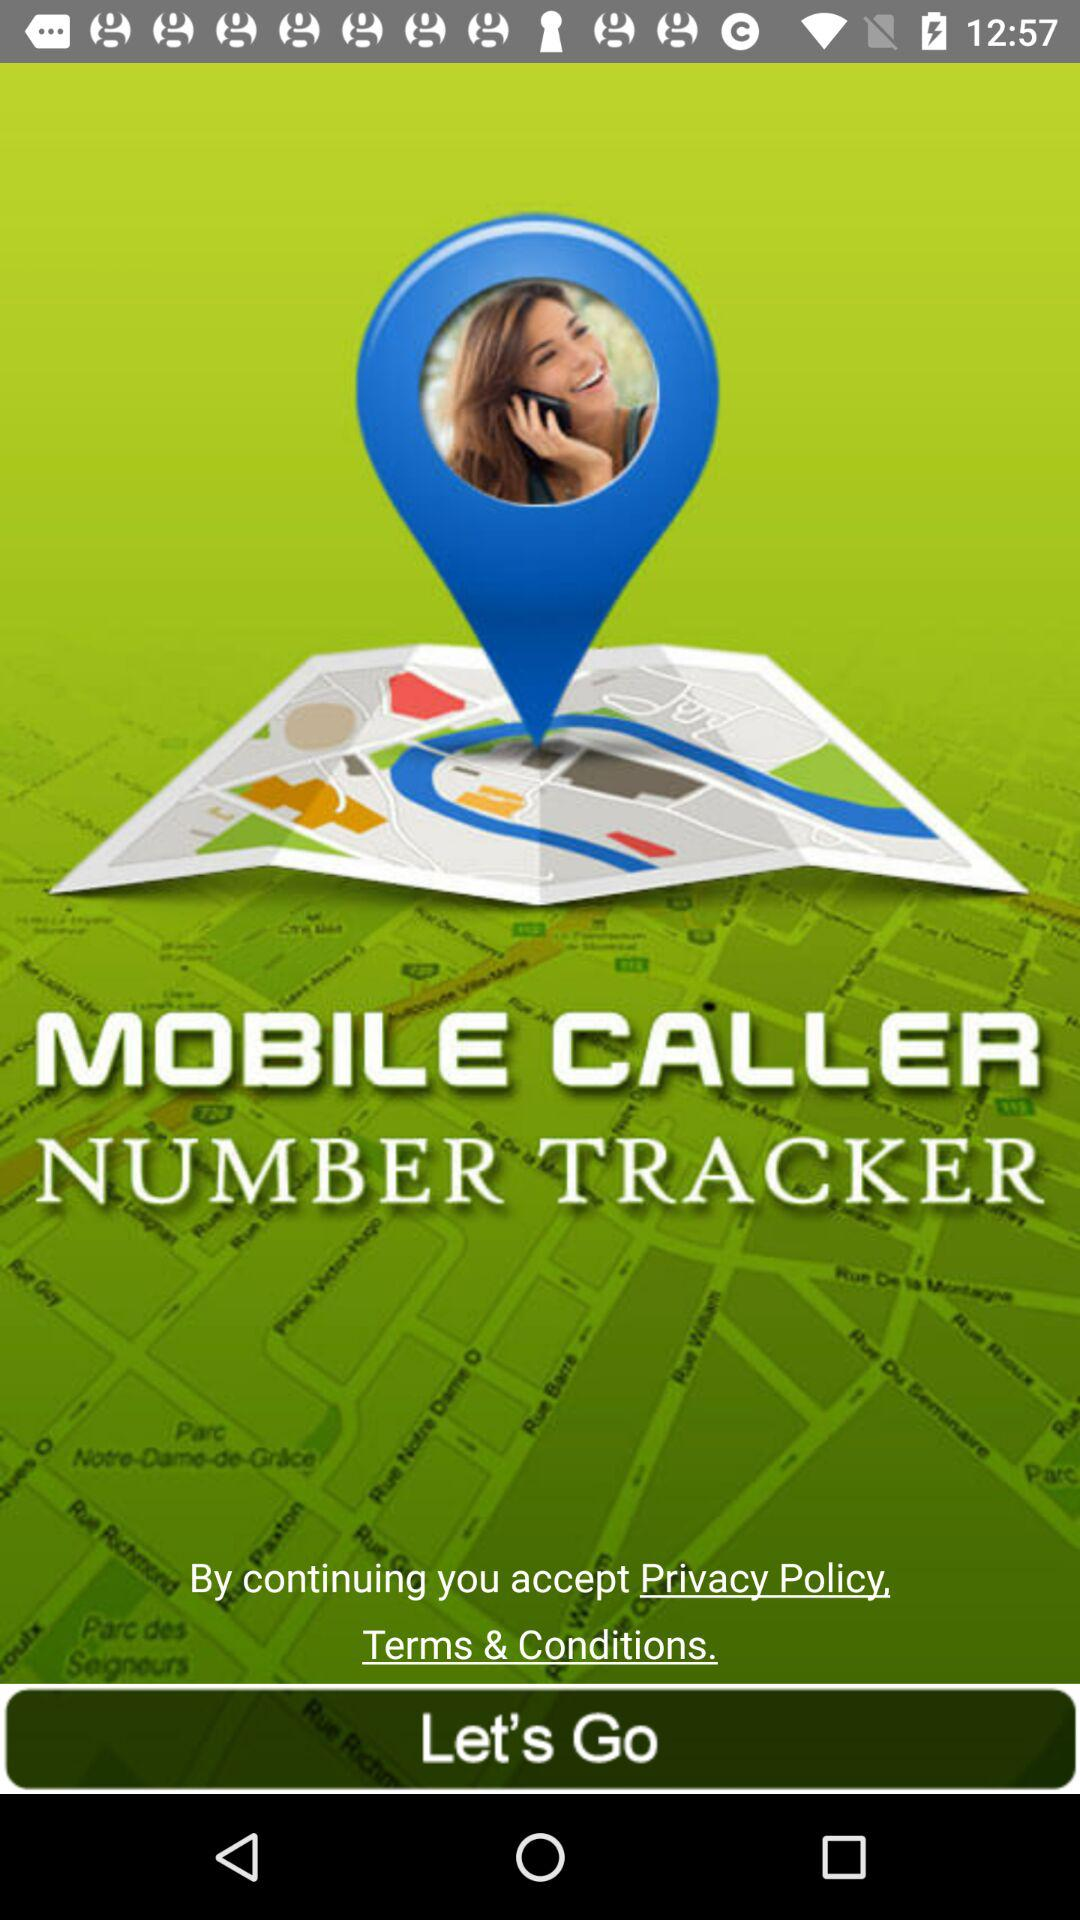What is the application name? The application name is "MOBILE CALLER NUMBER TRACKER". 